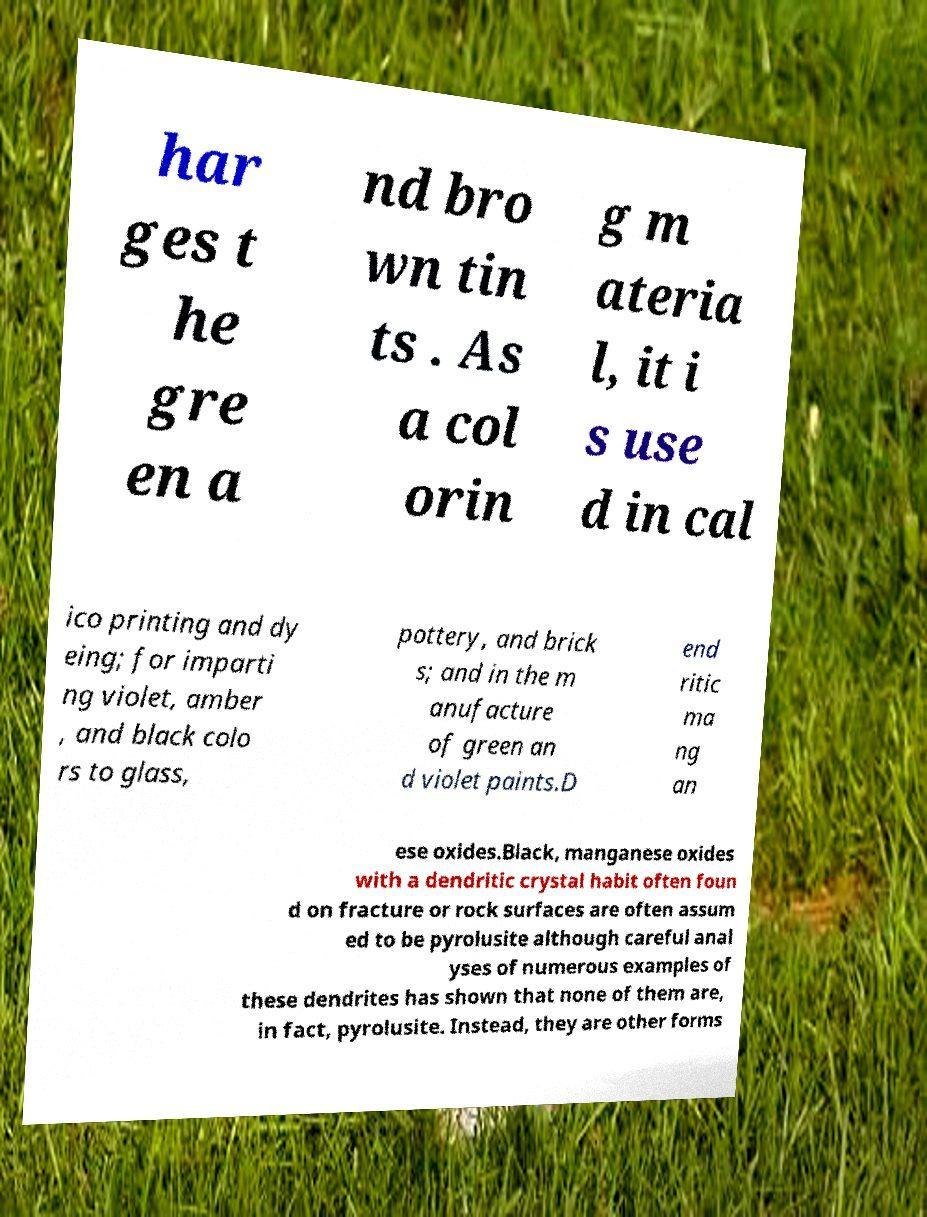Can you read and provide the text displayed in the image?This photo seems to have some interesting text. Can you extract and type it out for me? har ges t he gre en a nd bro wn tin ts . As a col orin g m ateria l, it i s use d in cal ico printing and dy eing; for imparti ng violet, amber , and black colo rs to glass, pottery, and brick s; and in the m anufacture of green an d violet paints.D end ritic ma ng an ese oxides.Black, manganese oxides with a dendritic crystal habit often foun d on fracture or rock surfaces are often assum ed to be pyrolusite although careful anal yses of numerous examples of these dendrites has shown that none of them are, in fact, pyrolusite. Instead, they are other forms 